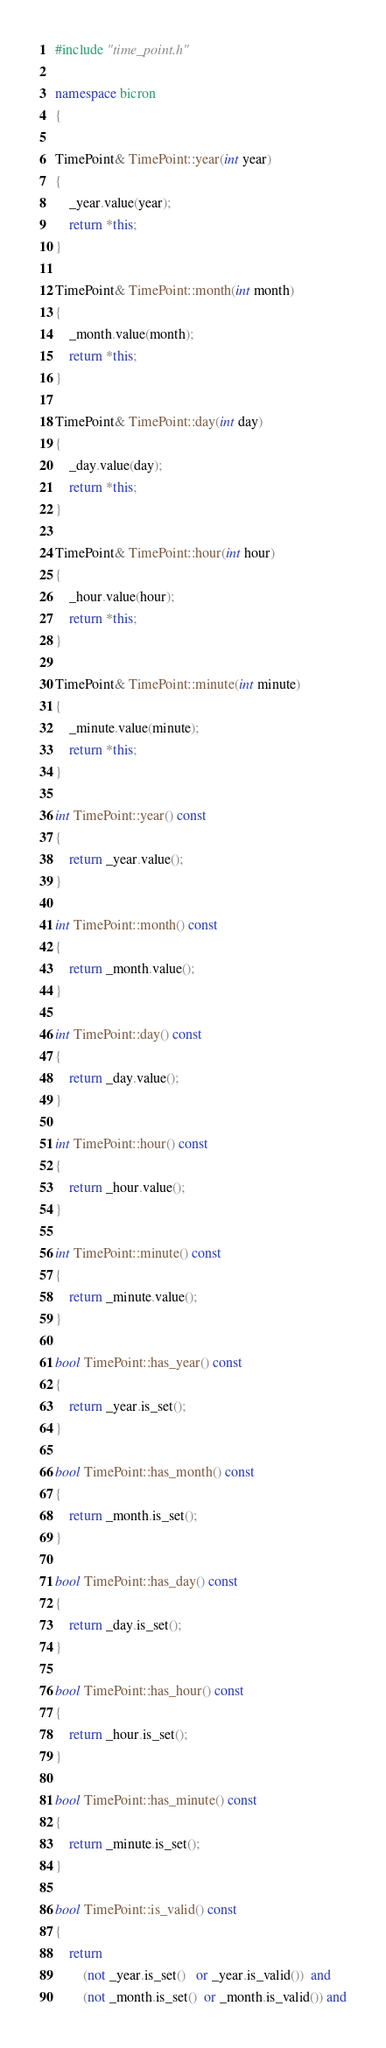Convert code to text. <code><loc_0><loc_0><loc_500><loc_500><_C++_>#include "time_point.h"

namespace bicron
{

TimePoint& TimePoint::year(int year)
{
	_year.value(year);
	return *this;
}

TimePoint& TimePoint::month(int month)
{
	_month.value(month);
	return *this;
}

TimePoint& TimePoint::day(int day)
{
	_day.value(day);
	return *this;
}

TimePoint& TimePoint::hour(int hour)
{
	_hour.value(hour);
	return *this;
}

TimePoint& TimePoint::minute(int minute)
{
	_minute.value(minute);
	return *this;
}

int TimePoint::year() const
{
	return _year.value();
}

int TimePoint::month() const
{
	return _month.value();
}

int TimePoint::day() const
{
	return _day.value();
}

int TimePoint::hour() const
{
	return _hour.value();
}

int TimePoint::minute() const
{
	return _minute.value();
}

bool TimePoint::has_year() const
{
	return _year.is_set();
}

bool TimePoint::has_month() const
{
	return _month.is_set();
}

bool TimePoint::has_day() const
{
	return _day.is_set();
}

bool TimePoint::has_hour() const
{
	return _hour.is_set();
}

bool TimePoint::has_minute() const
{
	return _minute.is_set();
}

bool TimePoint::is_valid() const
{
	return
		(not _year.is_set()   or _year.is_valid())  and
		(not _month.is_set()  or _month.is_valid()) and</code> 